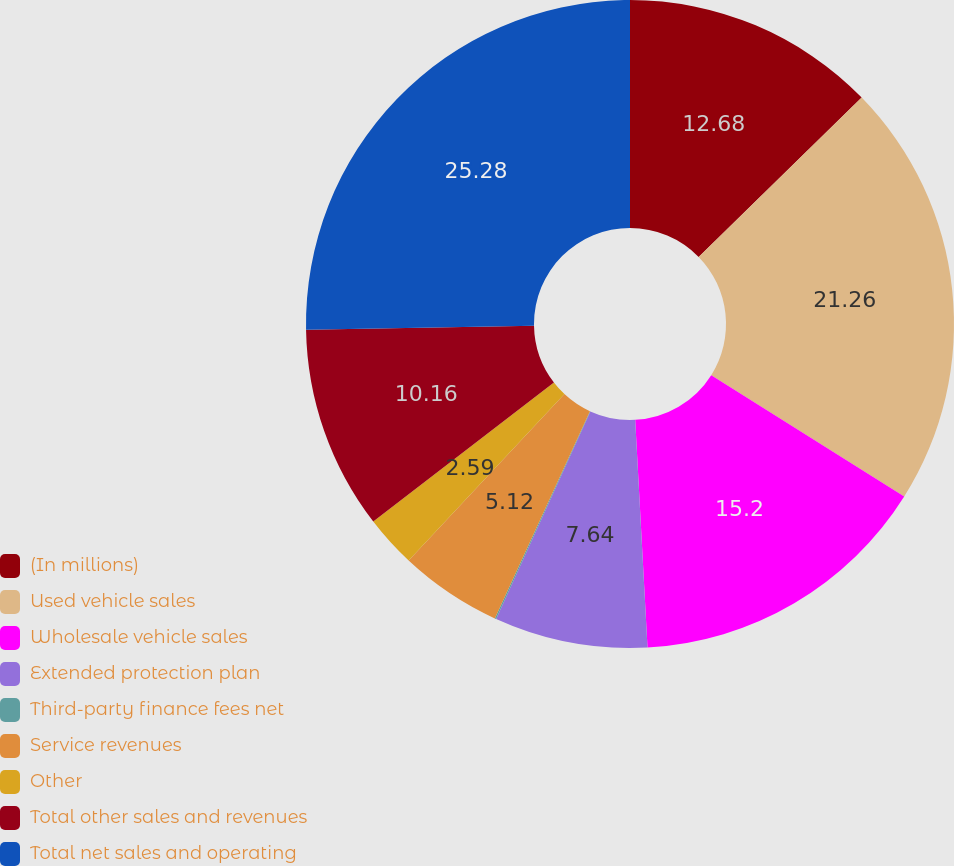<chart> <loc_0><loc_0><loc_500><loc_500><pie_chart><fcel>(In millions)<fcel>Used vehicle sales<fcel>Wholesale vehicle sales<fcel>Extended protection plan<fcel>Third-party finance fees net<fcel>Service revenues<fcel>Other<fcel>Total other sales and revenues<fcel>Total net sales and operating<nl><fcel>12.68%<fcel>21.26%<fcel>15.2%<fcel>7.64%<fcel>0.07%<fcel>5.12%<fcel>2.59%<fcel>10.16%<fcel>25.28%<nl></chart> 